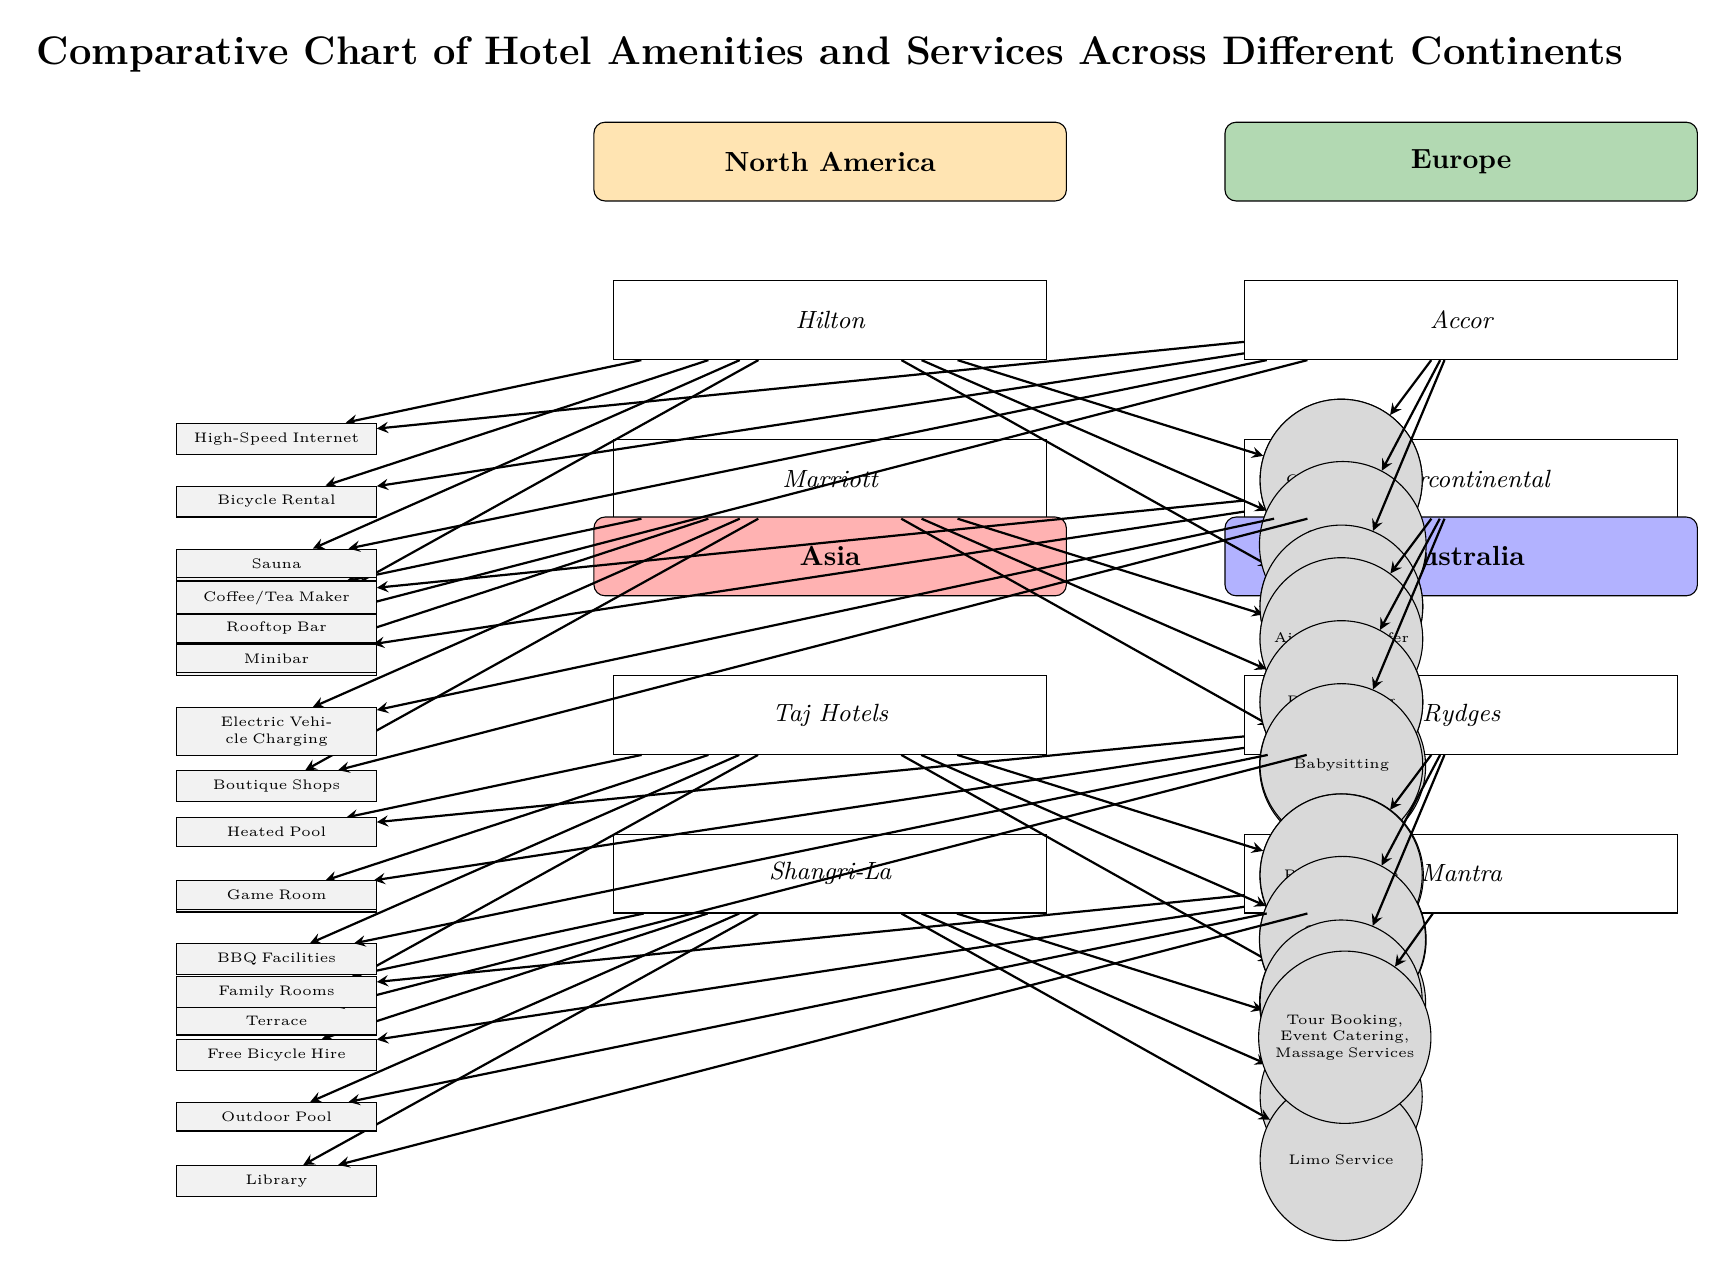What hotels are listed under North America? The diagram specifically mentions two hotels under the North America continent: Hilton and Marriott. These hotels are positioned directly below the North America label in the diagram.
Answer: Hilton, Marriott How many continents are represented in the diagram? The diagram shows four continents, which are North America, Europe, Asia, and Australia. Each continent has its own section on the diagram.
Answer: 4 Which hotel in Asia offers Yoga Classes as an amenity? According to the diagram, the Taj Hotels, located under the Asia continent, lists Yoga Classes among its amenities. This is evident in the list of amenities connected to the Taj Hotels node.
Answer: Taj Hotels What type of service is outlined for the hotel 'Marriott'? The diagram specifies a number of services provided by Marriott, such as Car Rental Desk, Laundry Service, and Conference Rooms. The services are shown on the right side of the Marriott hotel node.
Answer: Car Rental Desk, Laundry Service, Conference Rooms Which European hotel features a Rooftop Bar? The diagram shows that the Accor hotel, under the Europe continent, lists a Rooftop Bar as one of its amenities. The amenity is directly linked to the Accor hotel in the diagram.
Answer: Accor How many amenities does the hotel 'Shangri-La' provide? The Shangri-La hotel presents four distinct amenities listed directly below its name: Children's Play Area, Private Cinema, Gourmet Restaurant, and Seaview Room. Thus, there are four amenities provided by this hotel.
Answer: 4 What is the color representing Australia on the diagram? In the diagram, Australia is represented using a blue color scheme, indicated at the top section where the Australia continent label is placed.
Answer: Blue Which service do both Hilton and Intercontinental hotels offer? By comparing the services offered by both the Hilton and Intercontinental hotels, it is clear that both provide the service of a Business Center. This can be seen in the services listed for each hotel.
Answer: Business Center 